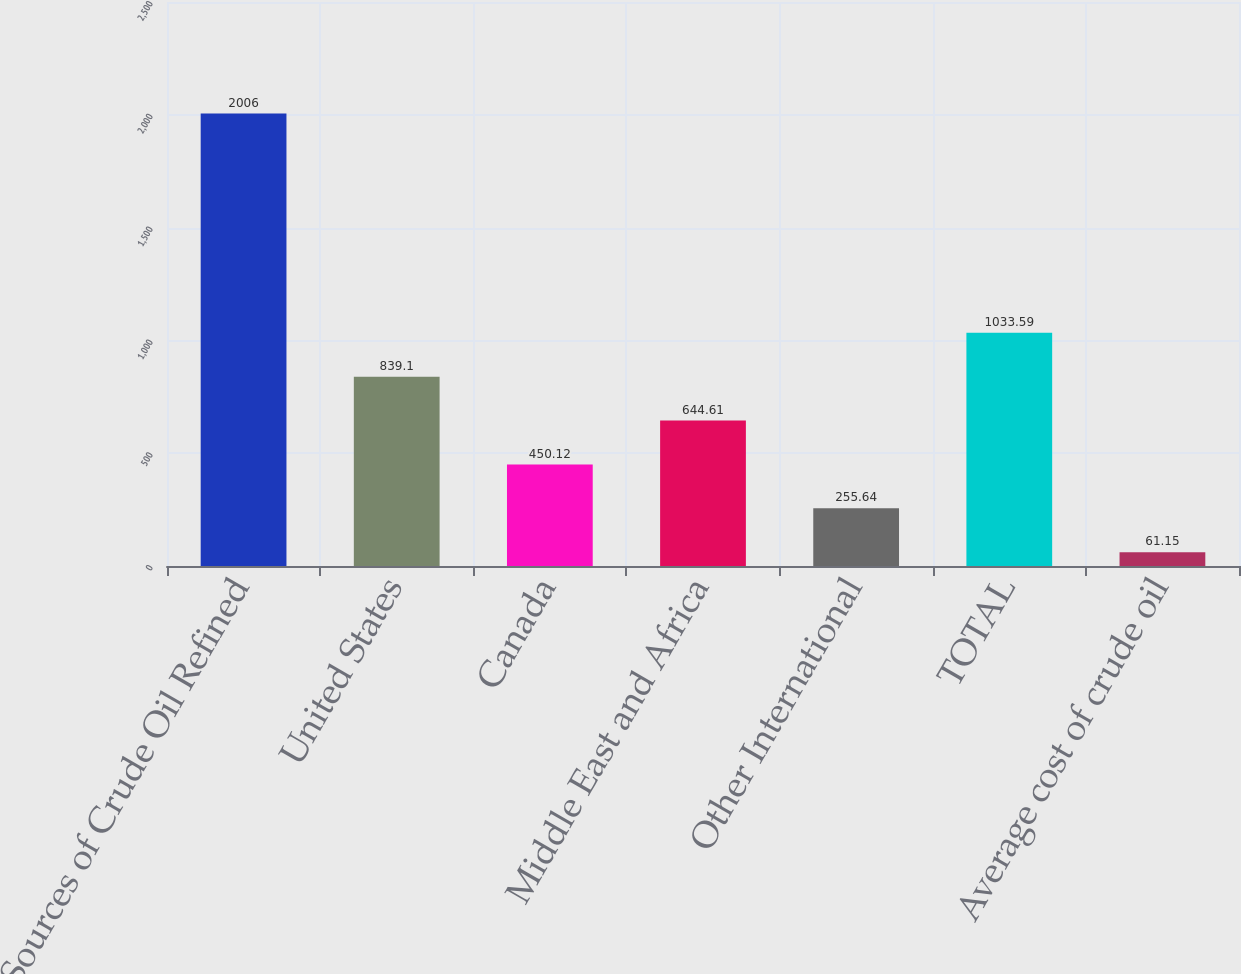Convert chart to OTSL. <chart><loc_0><loc_0><loc_500><loc_500><bar_chart><fcel>Sources of Crude Oil Refined<fcel>United States<fcel>Canada<fcel>Middle East and Africa<fcel>Other International<fcel>TOTAL<fcel>Average cost of crude oil<nl><fcel>2006<fcel>839.1<fcel>450.12<fcel>644.61<fcel>255.64<fcel>1033.59<fcel>61.15<nl></chart> 